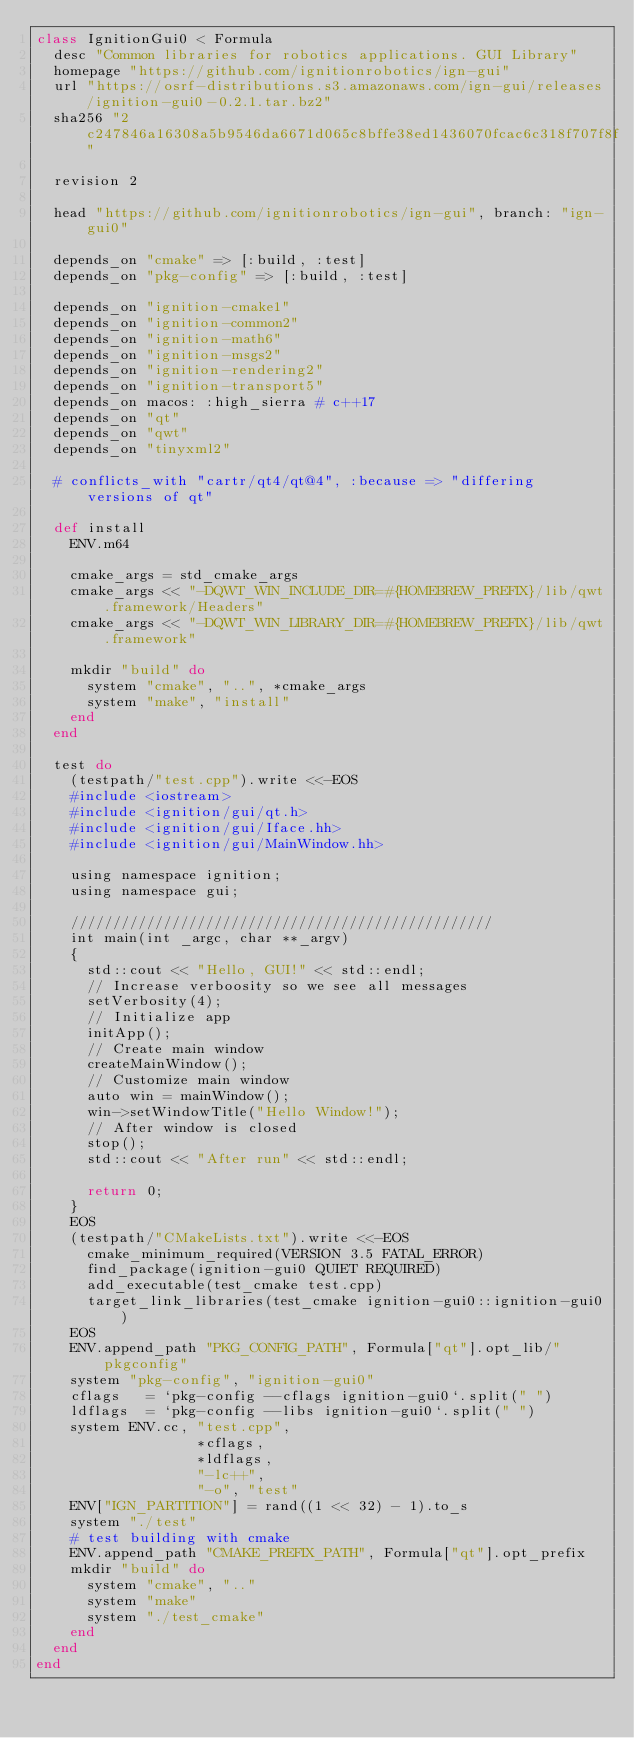<code> <loc_0><loc_0><loc_500><loc_500><_Ruby_>class IgnitionGui0 < Formula
  desc "Common libraries for robotics applications. GUI Library"
  homepage "https://github.com/ignitionrobotics/ign-gui"
  url "https://osrf-distributions.s3.amazonaws.com/ign-gui/releases/ignition-gui0-0.2.1.tar.bz2"
  sha256 "2c247846a16308a5b9546da6671d065c8bffe38ed1436070fcac6c318f707f8f"
  
  revision 2

  head "https://github.com/ignitionrobotics/ign-gui", branch: "ign-gui0"

  depends_on "cmake" => [:build, :test]
  depends_on "pkg-config" => [:build, :test]

  depends_on "ignition-cmake1"
  depends_on "ignition-common2"
  depends_on "ignition-math6"
  depends_on "ignition-msgs2"
  depends_on "ignition-rendering2"
  depends_on "ignition-transport5"
  depends_on macos: :high_sierra # c++17
  depends_on "qt"
  depends_on "qwt"
  depends_on "tinyxml2"

  # conflicts_with "cartr/qt4/qt@4", :because => "differing versions of qt"

  def install
    ENV.m64

    cmake_args = std_cmake_args
    cmake_args << "-DQWT_WIN_INCLUDE_DIR=#{HOMEBREW_PREFIX}/lib/qwt.framework/Headers"
    cmake_args << "-DQWT_WIN_LIBRARY_DIR=#{HOMEBREW_PREFIX}/lib/qwt.framework"

    mkdir "build" do
      system "cmake", "..", *cmake_args
      system "make", "install"
    end
  end

  test do
    (testpath/"test.cpp").write <<-EOS
    #include <iostream>
    #include <ignition/gui/qt.h>
    #include <ignition/gui/Iface.hh>
    #include <ignition/gui/MainWindow.hh>

    using namespace ignition;
    using namespace gui;

    //////////////////////////////////////////////////
    int main(int _argc, char **_argv)
    {
      std::cout << "Hello, GUI!" << std::endl;
      // Increase verboosity so we see all messages
      setVerbosity(4);
      // Initialize app
      initApp();
      // Create main window
      createMainWindow();
      // Customize main window
      auto win = mainWindow();
      win->setWindowTitle("Hello Window!");
      // After window is closed
      stop();
      std::cout << "After run" << std::endl;

      return 0;
    }
    EOS
    (testpath/"CMakeLists.txt").write <<-EOS
      cmake_minimum_required(VERSION 3.5 FATAL_ERROR)
      find_package(ignition-gui0 QUIET REQUIRED)
      add_executable(test_cmake test.cpp)
      target_link_libraries(test_cmake ignition-gui0::ignition-gui0)
    EOS
    ENV.append_path "PKG_CONFIG_PATH", Formula["qt"].opt_lib/"pkgconfig"
    system "pkg-config", "ignition-gui0"
    cflags   = `pkg-config --cflags ignition-gui0`.split(" ")
    ldflags  = `pkg-config --libs ignition-gui0`.split(" ")
    system ENV.cc, "test.cpp",
                   *cflags,
                   *ldflags,
                   "-lc++",
                   "-o", "test"
    ENV["IGN_PARTITION"] = rand((1 << 32) - 1).to_s
    system "./test"
    # test building with cmake
    ENV.append_path "CMAKE_PREFIX_PATH", Formula["qt"].opt_prefix
    mkdir "build" do
      system "cmake", ".."
      system "make"
      system "./test_cmake"
    end
  end
end
</code> 